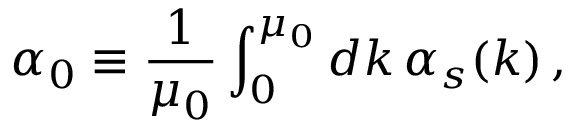Convert formula to latex. <formula><loc_0><loc_0><loc_500><loc_500>\alpha _ { 0 } \equiv \frac { 1 } { \mu _ { 0 } } \int _ { 0 } ^ { \mu _ { 0 } } d k \, \alpha _ { s } ( k ) \, ,</formula> 